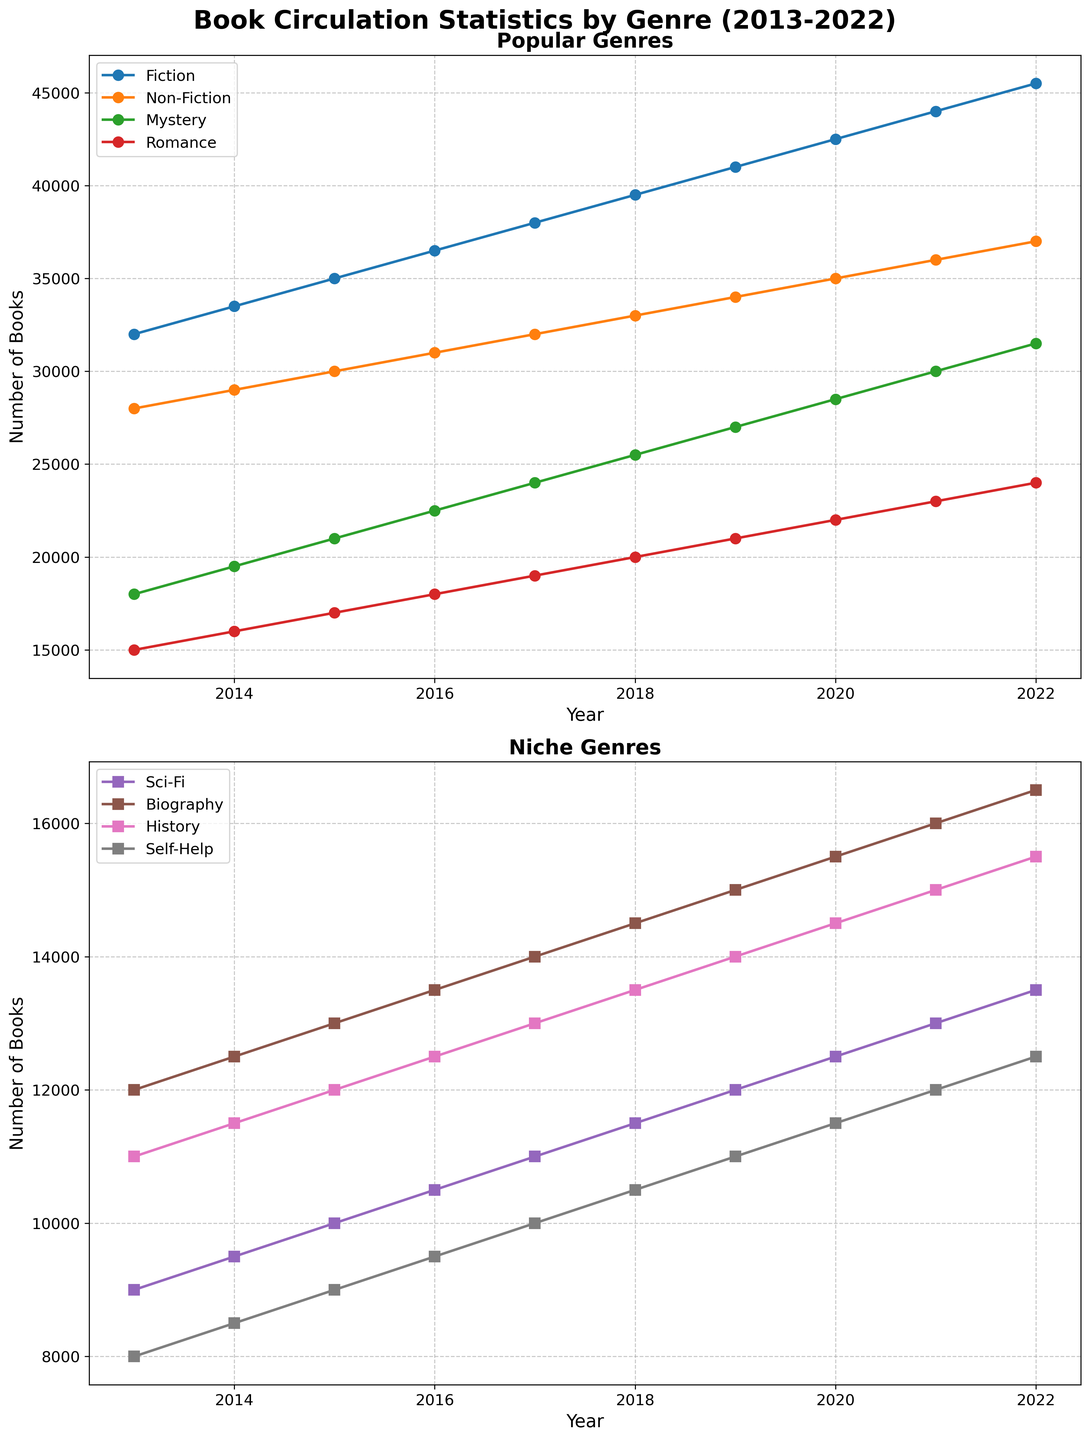Which genre shows the highest increase in circulation from 2013 to 2022 among the popular genres? To find the genre with the highest increase in circulation from 2013 to 2022 within popular genres (Fiction, Non-Fiction, Mystery, Romance), calculate the difference between the 2022 and 2013 values for each genre. Fiction: 45500 - 32000 = 13500, Non-Fiction: 37000 - 28000 = 9000, Mystery: 31500 - 18000 = 13500, Romance: 24000 - 15000 = 9000. Thus, Fiction and Mystery both show the highest increase of 13500.
Answer: Fiction and Mystery By how much did Sci-Fi circulation increase between 2018 and 2021? To determine the increase, subtract the circulation in 2018 from the circulation in 2021 for the Sci-Fi genre. Sci-Fi in 2021 is 13000, and in 2018 it is 11500. The increase is 13000 - 11500 = 1500.
Answer: 1500 What is the average circulation of the Mystery genre over the entire period? To find the average, sum the circulations from 2013 to 2022 and divide by the number of years. (18000 + 19500 + 21000 + 22500 + 24000 + 25500 + 27000 + 28500 + 30000 + 31500) / 10 = 247500 / 10 = 24750.
Answer: 24750 Which niche genre had the most significant circulation in 2020? Among the niche genres (Sci-Fi, Biography, History, Self-Help) in 2020, Sci-Fi had 12500, Biography 15500, History 14500, Self-Help 11500. Biography has the highest circulation at 15500.
Answer: Biography Which genres are represented by circles in the first subplot? The genres represented by circles in the first subplot are those mentioned in that subplot with circle markers. From the description, they are Fiction, Non-Fiction, Mystery, and Romance.
Answer: Fiction, Non-Fiction, Mystery, Romance 